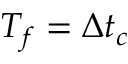Convert formula to latex. <formula><loc_0><loc_0><loc_500><loc_500>T _ { f } = \Delta t _ { c }</formula> 